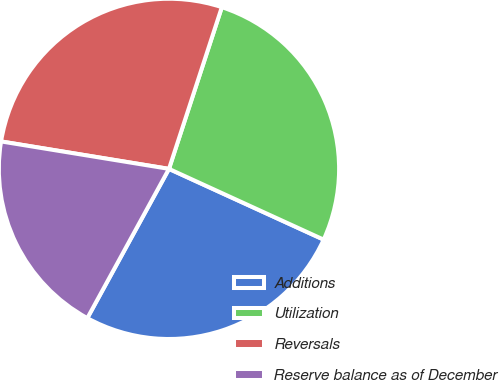<chart> <loc_0><loc_0><loc_500><loc_500><pie_chart><fcel>Additions<fcel>Utilization<fcel>Reversals<fcel>Reserve balance as of December<nl><fcel>26.14%<fcel>26.8%<fcel>27.45%<fcel>19.61%<nl></chart> 